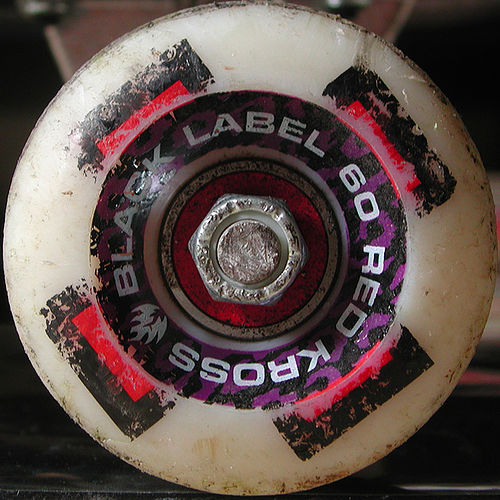<image>
Is there a nut in the wheel? Yes. The nut is contained within or inside the wheel, showing a containment relationship. 